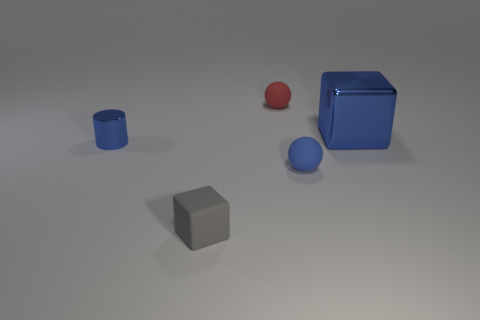Are there any other things that are the same size as the blue cube?
Your answer should be compact. No. There is a block that is behind the metallic cylinder; what color is it?
Ensure brevity in your answer.  Blue. What is the color of the other tiny matte object that is the same shape as the blue matte object?
Keep it short and to the point. Red. Is there any other thing that has the same color as the small matte block?
Give a very brief answer. No. Are there more large blue shiny cubes than blocks?
Give a very brief answer. No. Is the material of the big blue object the same as the blue cylinder?
Your answer should be very brief. Yes. What number of big brown objects have the same material as the small blue sphere?
Make the answer very short. 0. Is the size of the red thing the same as the cube that is behind the tiny blue metal object?
Your answer should be very brief. No. There is a tiny rubber thing that is both left of the small blue ball and to the right of the small gray cube; what color is it?
Your response must be concise. Red. There is a sphere in front of the blue cube; is there a tiny red object to the right of it?
Keep it short and to the point. No. 